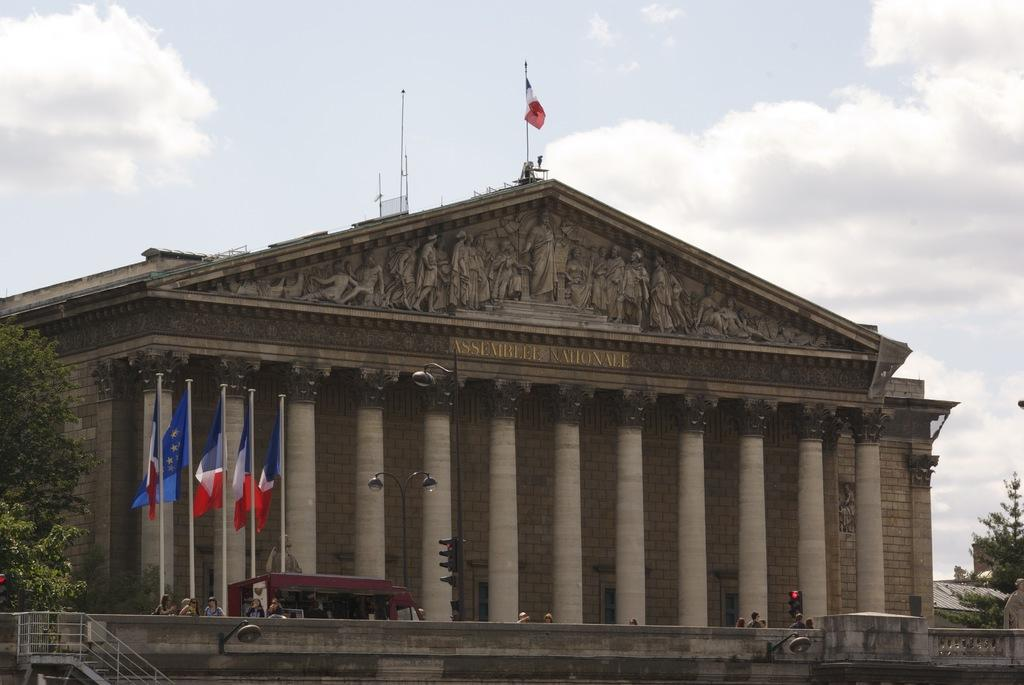What type of structure is visible in the image? There is a building in the image. What architectural feature can be seen on the building? The building has pillars. What additional objects are present in the image? There are flags, people, a tree, a traffic signal, and the sky is visible. How many flags are present in the image? There are flags in the image, but the exact number is not specified. What is the weather like in the image? The sky is cloudy in the image. What type of box is being used to increase the flavor of the stew in the image? There is no box, stew, or any mention of increasing flavor in the image. 